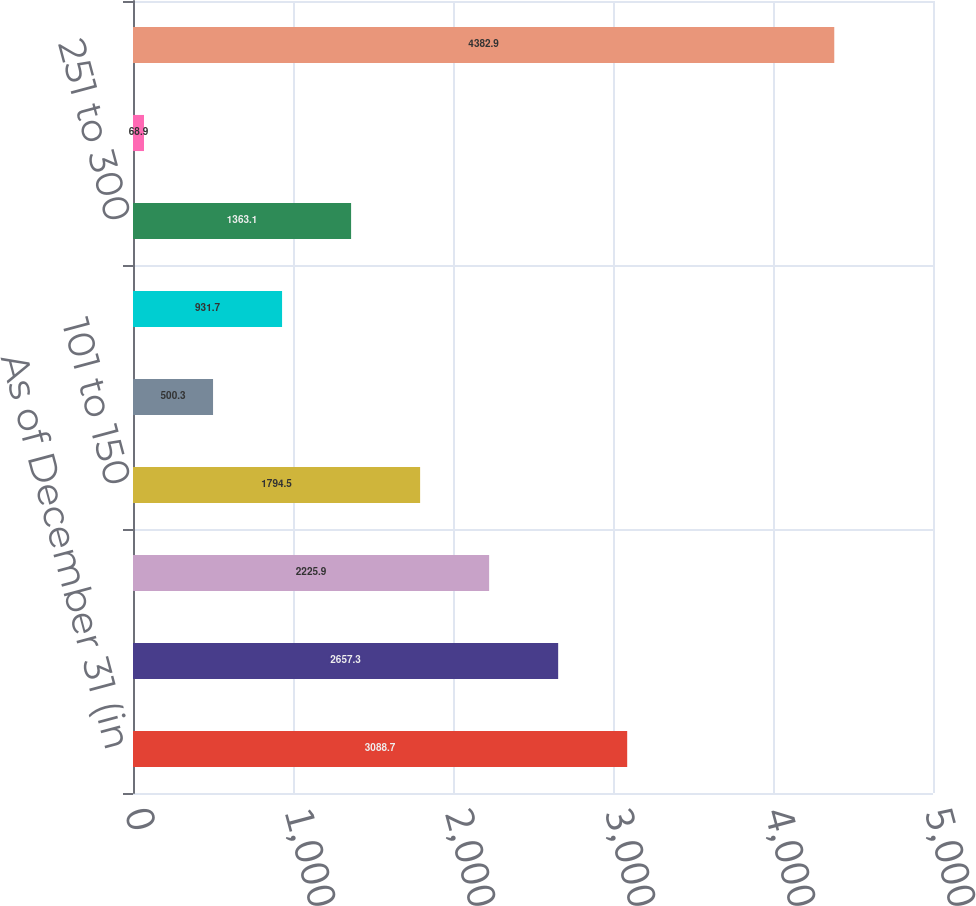Convert chart. <chart><loc_0><loc_0><loc_500><loc_500><bar_chart><fcel>As of December 31 (in<fcel>050 or less<fcel>051 to 100<fcel>101 to 150<fcel>151 to 200<fcel>201 to 250<fcel>251 to 300<fcel>301 and greater<fcel>Total<nl><fcel>3088.7<fcel>2657.3<fcel>2225.9<fcel>1794.5<fcel>500.3<fcel>931.7<fcel>1363.1<fcel>68.9<fcel>4382.9<nl></chart> 